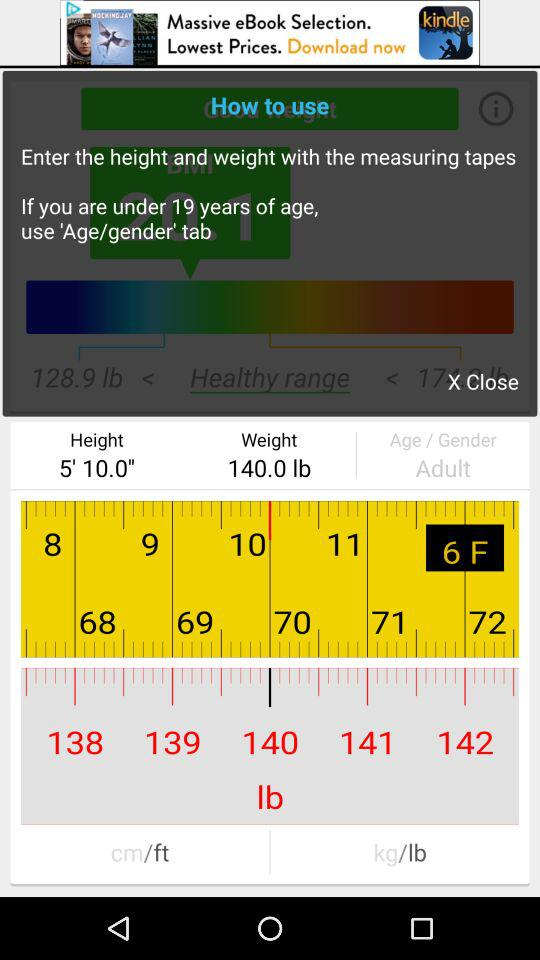What is the height? The height is 5 feet 10 inches. 